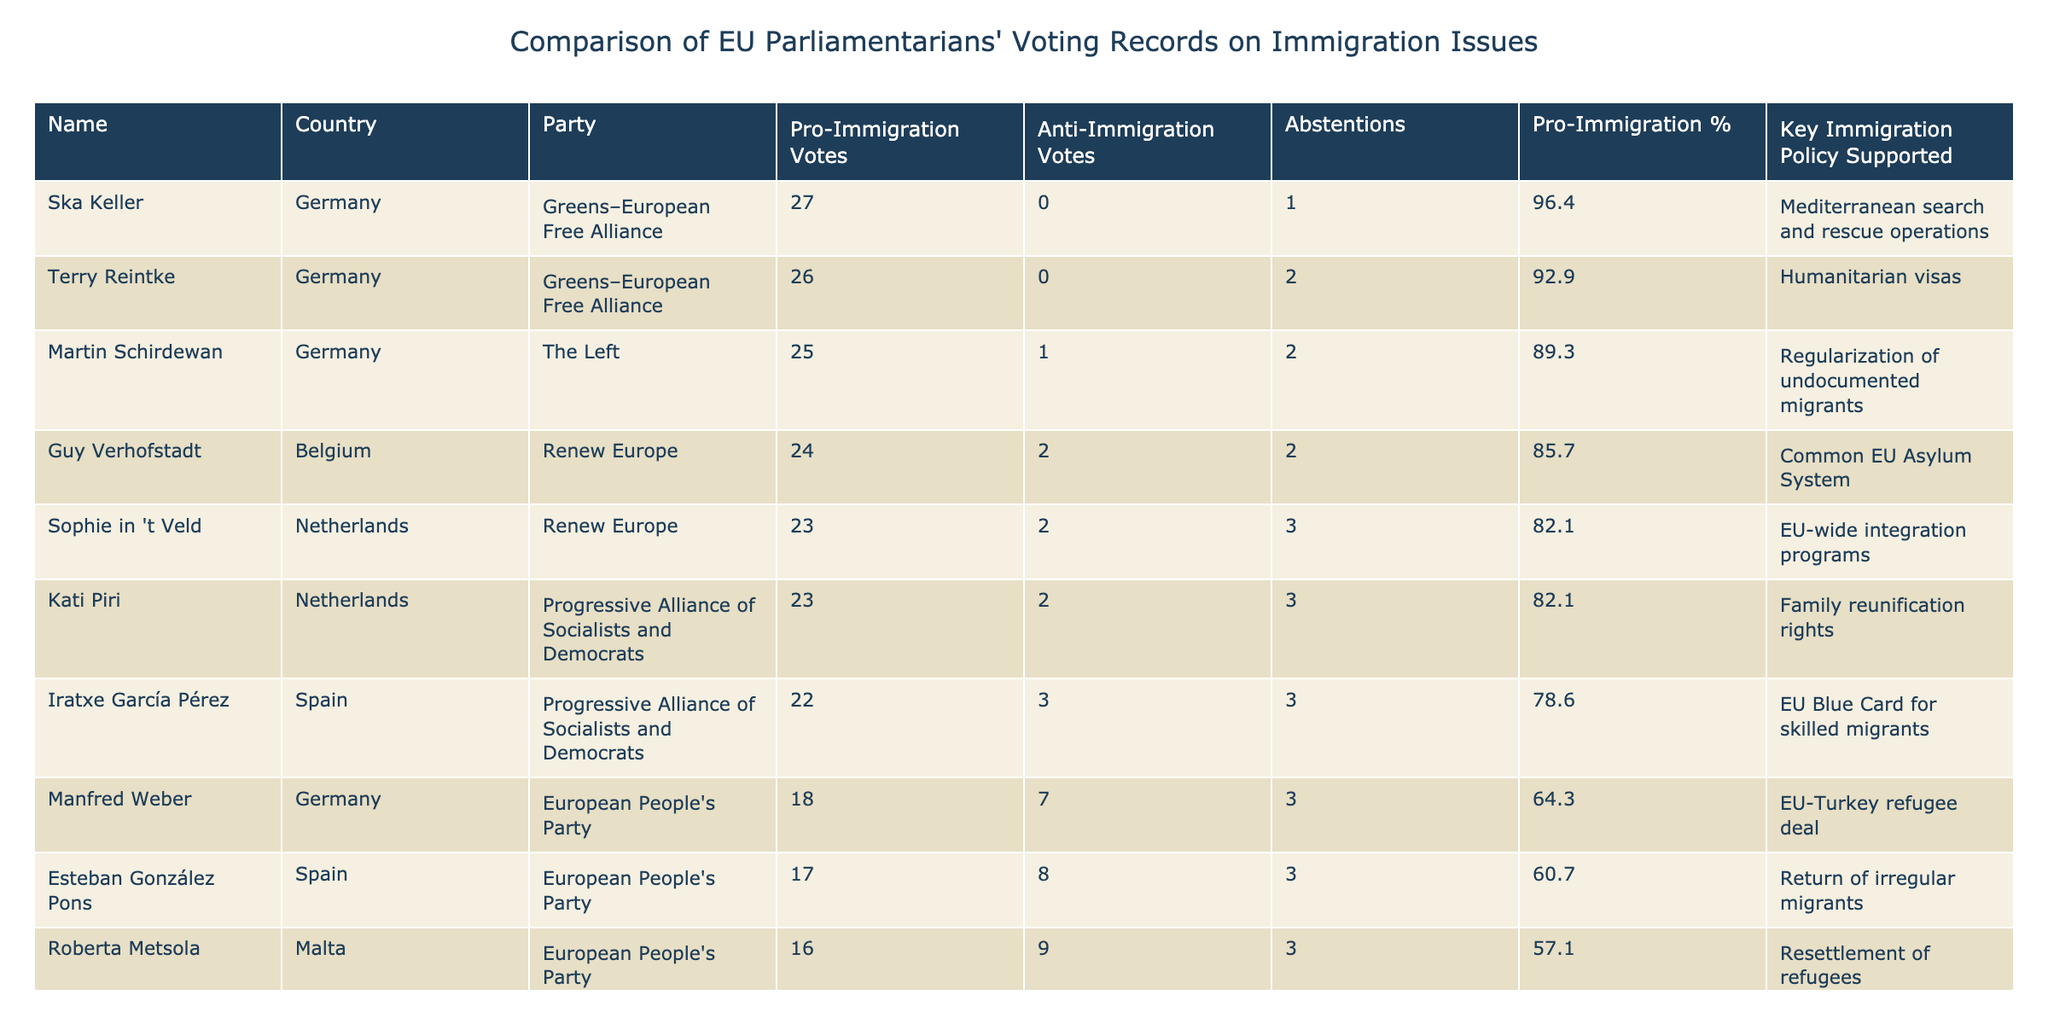What is the highest number of pro-immigration votes among the parliamentarians? The table shows that Ska Keller from Germany has 27 pro-immigration votes, which is the highest among all listed parliamentarians.
Answer: 27 Which parliamentarian has the most anti-immigration votes? Marco Zanni from Italy has the most anti-immigration votes with 26, as indicated in the table.
Answer: 26 What is the average percentage of pro-immigration votes for the members of the European People's Party? The pro-immigration votes for the European People's Party members are 18 (Weber) and 16 (Metsola). The total pro-immigration votes = 34, total votes = (18 + 7 + 3) + (16 + 9 + 3) = 56. The average percentage of pro-immigration votes is (34/56)*100 = 60.7%.
Answer: 60.7% Did all parliamentarians from the Greens–European Free Alliance vote pro-immigration? Yes, both Ska Keller and Terry Reintke from the Greens–European Free Alliance voted pro-immigration with 27 and 26 votes, respectively, and have zero anti-immigration votes.
Answer: Yes Which country has the parliamentarian with the highest pro-immigration voting percentage, and what is that percentage? Ska Keller from Germany has the highest pro-immigration voting percentage at 96.4%, calculated as (27/(27+0+1))*100. This is higher than any other parliamentarian listed.
Answer: 96.4% How many abstentions were recorded by the province that has the lowest pro-immigration votes? Marco Zanni from Italy has the lowest pro-immigration votes at 2 and has no abstentions, while all others have at least some. However, abstentions do not overlap with the lowest pro-immigration votes.
Answer: 0 What is the difference in pro-immigration votes between the parliamentarian with the highest and the lowest pro-immigration votes? The highest pro-immigration votes are 27 (Ska Keller) and the lowest are 2 (Marco Zanni). The difference is 27 - 2 = 25.
Answer: 25 Has any parliamentarian supported the "Common EU Asylum System"? Yes, Guy Verhofstadt from Belgium supported the "Common EU Asylum System" and has a solid voting record of 24 pro-immigration votes.
Answer: Yes 